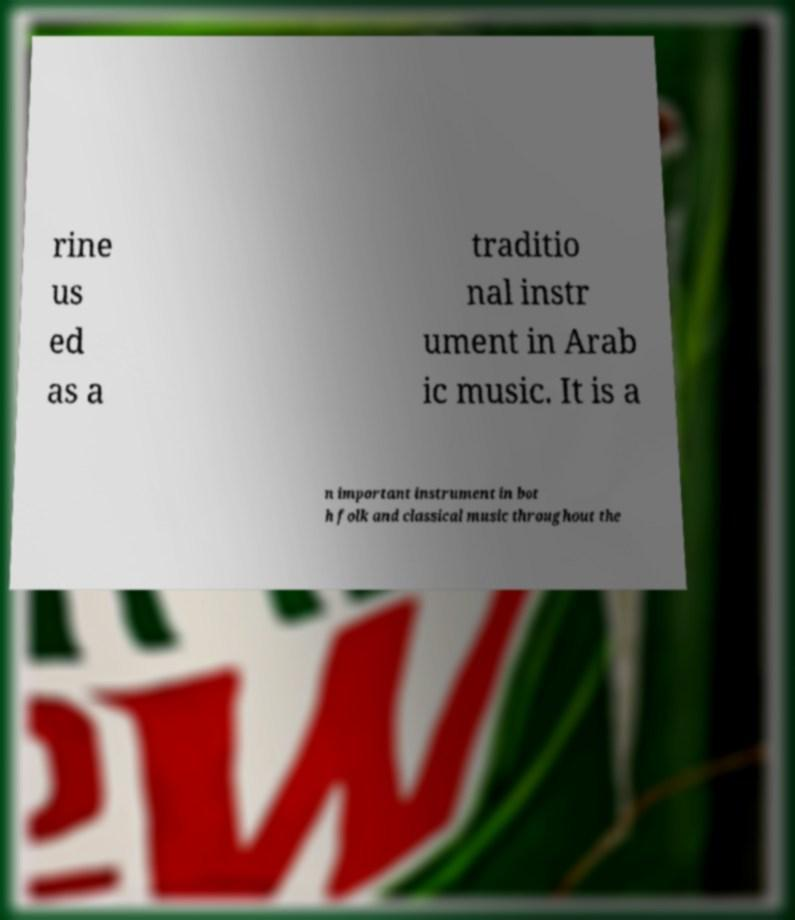For documentation purposes, I need the text within this image transcribed. Could you provide that? rine us ed as a traditio nal instr ument in Arab ic music. It is a n important instrument in bot h folk and classical music throughout the 